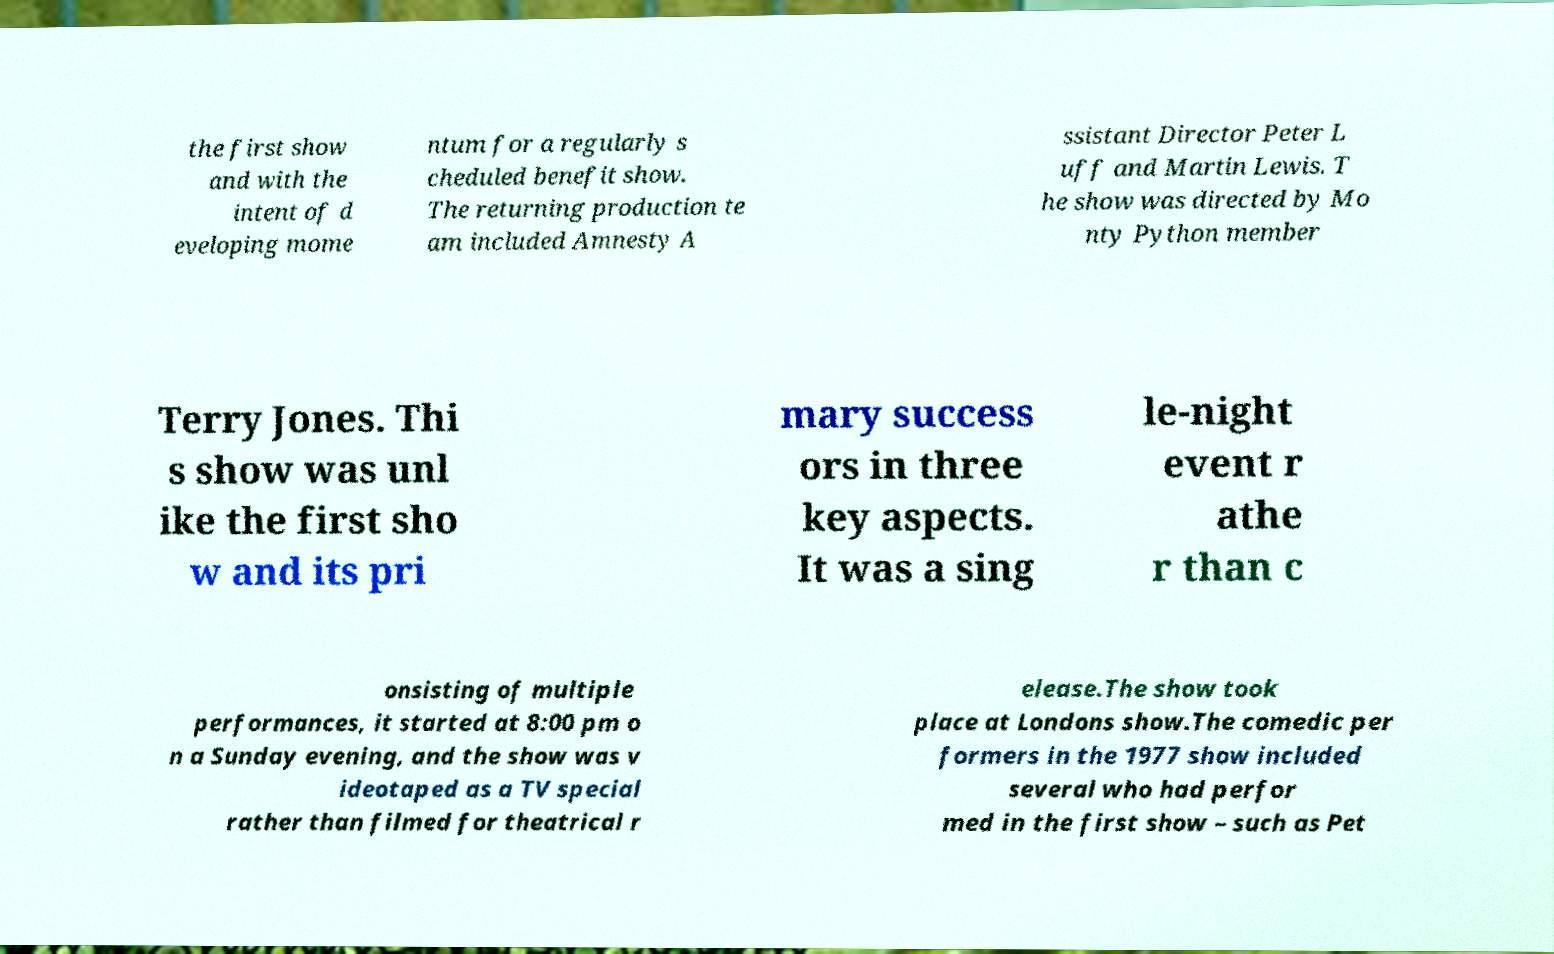What messages or text are displayed in this image? I need them in a readable, typed format. the first show and with the intent of d eveloping mome ntum for a regularly s cheduled benefit show. The returning production te am included Amnesty A ssistant Director Peter L uff and Martin Lewis. T he show was directed by Mo nty Python member Terry Jones. Thi s show was unl ike the first sho w and its pri mary success ors in three key aspects. It was a sing le-night event r athe r than c onsisting of multiple performances, it started at 8:00 pm o n a Sunday evening, and the show was v ideotaped as a TV special rather than filmed for theatrical r elease.The show took place at Londons show.The comedic per formers in the 1977 show included several who had perfor med in the first show – such as Pet 